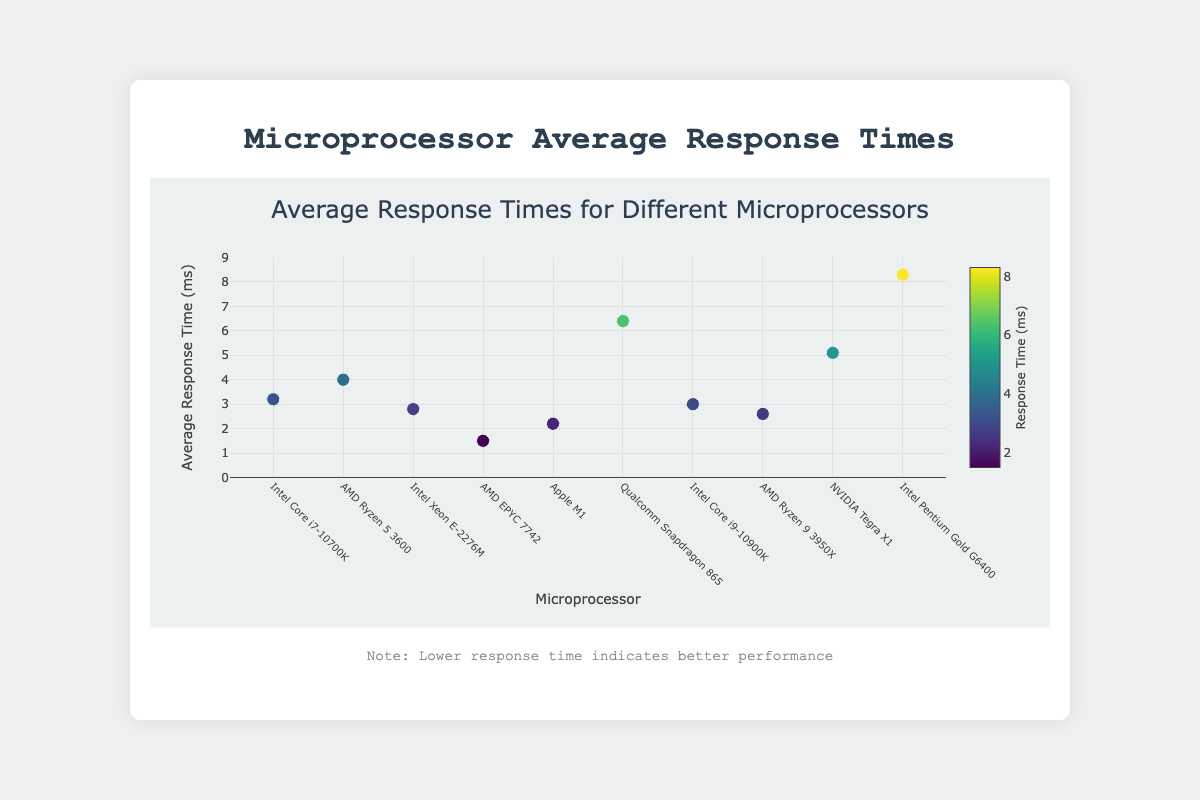What is the title of the scatter plot? The title of the scatter plot is usually displayed at the top of the plot and provides a concise summary of the data being visualized.
Answer: Microprocessor Average Response Times How many microprocessors are plotted in the scatter plot? To find the number of microprocessors, we count each unique microprocessor listed along the x-axis or each marker representing a data point in the scatter plot.
Answer: 10 Which microprocessor has the lowest average response time? Locate the data point with the lowest value on the y-axis, which represents the average response time in milliseconds. This data point corresponds to the microprocessor with the best performance (lowest response time).
Answer: AMD EPYC 7742 What is the average response time of the Napa Valley region? The average response time for "Qualcomm Snapdragon 865" can be directly read from the y-axis by finding the corresponding point on the plot. This URL is 100 milliseconds.
Answer: 100 List the microprocessors with average response times lower than 3 milliseconds. Identify all data points with y-values less than 3, then list the corresponding microprocessors from the x-axis labels.
Answer: Intel Xeon E-2276M, AMD EPYC 7742, Apple M1, AMD Ryzen 9 3950X What is the difference in average response time between AMD Ryzen 9 3950X and Intel Pentium Gold G6400? Locate the average response times for both microprocessors on the y-axis, then subtract the former's response time from the latter's. "Intel Pentium Gold G6400" has a response time of 8.3 ms, and “AMD Ryzen 9 3950X” has 2.6 ms. Subtract these to find the difference: 8.3 ms - 2.6 ms = 5.7 ms.
Answer: 5.7 ms Which microprocessor shows the highest average response time, and what is its value? Identify the data point with the highest value on the y-axis, which represents the microprocessor with the highest average response time, and note down its value.
Answer: Intel Pentium Gold G6400, 8.3 ms Order the top three best-performing microprocessors based on their average response times. To identify the best-performing microprocessors, sort the data points in ascending order by their y-values (average response times) and pick the top three. The three microprocessors with the lowest response times are: 1. AMD EPYC 7742 (1.5 ms), 2. Apple M1 (2.2 ms), 3. AMD Ryzen 9 3950X (2.6 ms).
Answer: AMD EPYC 7742, Apple M1, AMD Ryzen 9 3950X What is the median average response time of all listed microprocessors? List all average response times in ascending order and find the middle value since there is an odd number of data points. The sorted responses are: 1.5 ms, 2.2 ms, 2.6 ms, 2.8 ms, 3.0 ms, 3.2 ms, 4.0 ms, 5.1 ms, 6.4 ms, 8.3 ms. The median is the middle value: 3.0 ms.
Answer: 3.0 ms What is the range of the response times for the microprocessors? Calculate the range by subtracting the smallest response time from the highest response time. The minimum value is 1.5 ms (AMD EPYC 7742), and the maximum is 8.3 ms (Intel Pentium Gold G6400). Range = 8.3 ms - 1.5 ms = 6.8 ms.
Answer: 6.8 ms 